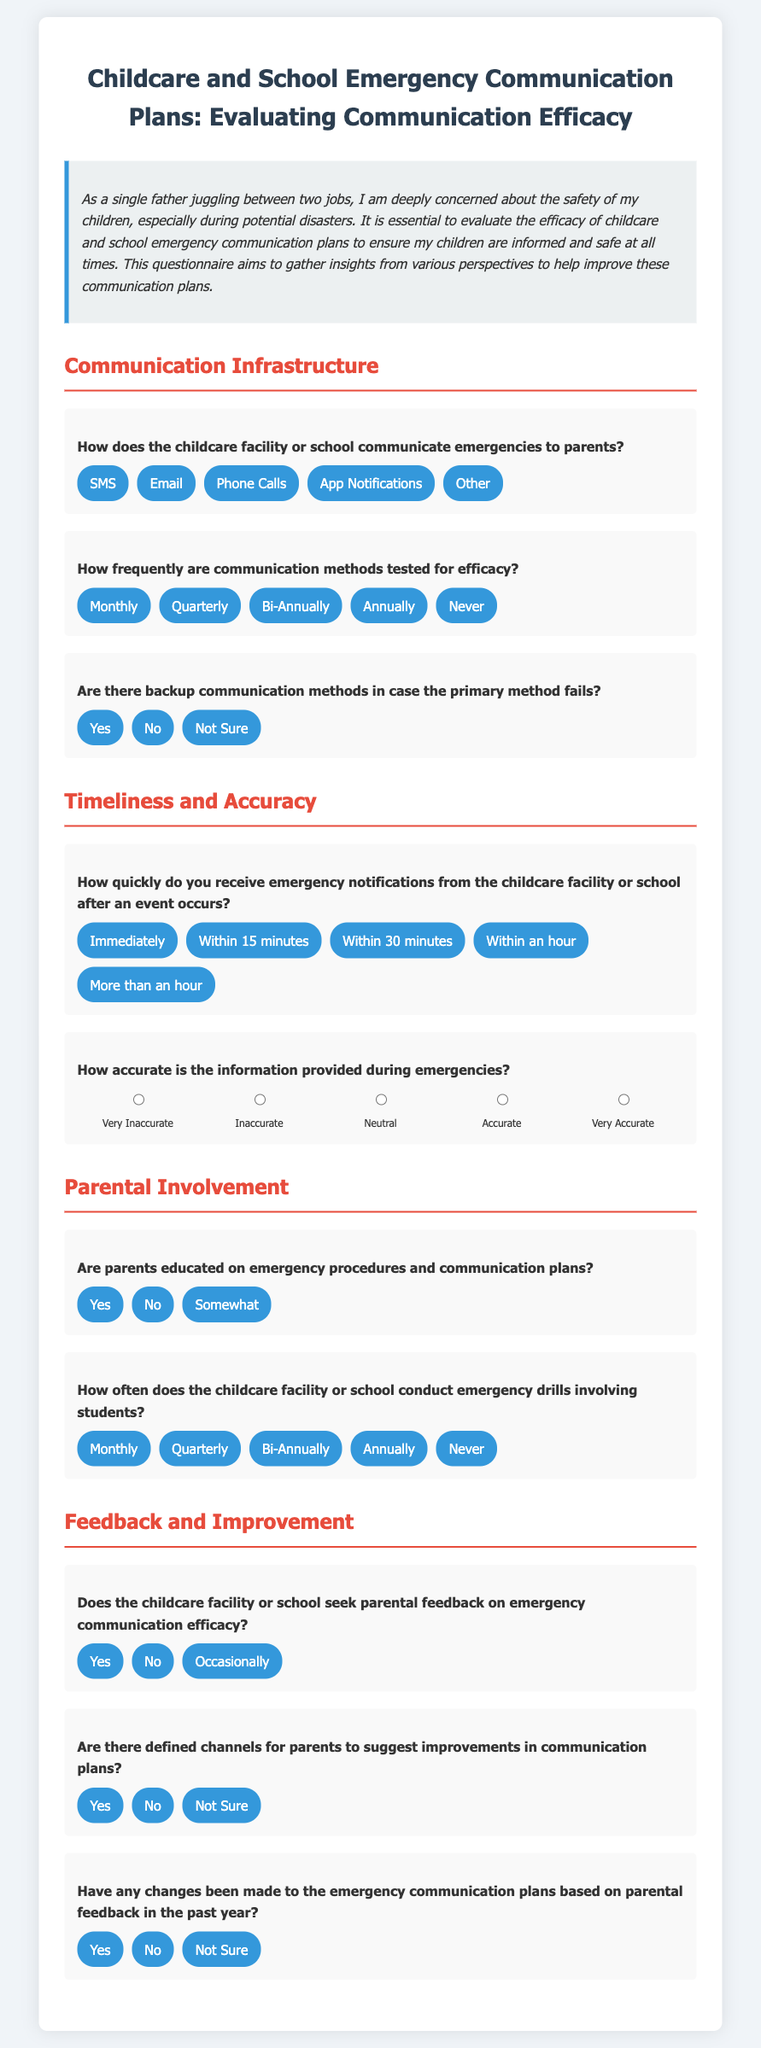What is the title of the document? The title is the main heading at the top of the document that describes its purpose.
Answer: Childcare and School Emergency Communication Plans: Evaluating Communication Efficacy How does the childcare facility or school communicate emergencies to parents? This information can be found in the section regarding communication methods, where various options are listed.
Answer: SMS How frequently are communication methods tested for efficacy? This question pertains to the frequency options provided in the communication infrastructure section of the document.
Answer: Monthly How quickly do you receive emergency notifications from the childcare facility or school? This query can be answered by reviewing the available options for the timing of received notifications.
Answer: Immediately Are parents educated on emergency procedures and communication plans? This question addresses whether parents receive information on procedures and plans according to the childcare facility or school.
Answer: Yes Does the childcare facility or school seek parental feedback on emergency communication efficacy? This information is found in the feedback and improvement section addressing communication efficacy feedback.
Answer: Yes How often does the childcare facility or school conduct emergency drills involving students? This question looks for the frequency of emergency drills, which is specified in the document's relevant section.
Answer: Monthly Are there defined channels for parents to suggest improvements in communication plans? This relates to the structure and availability of communication channels outlined in the document.
Answer: Yes 